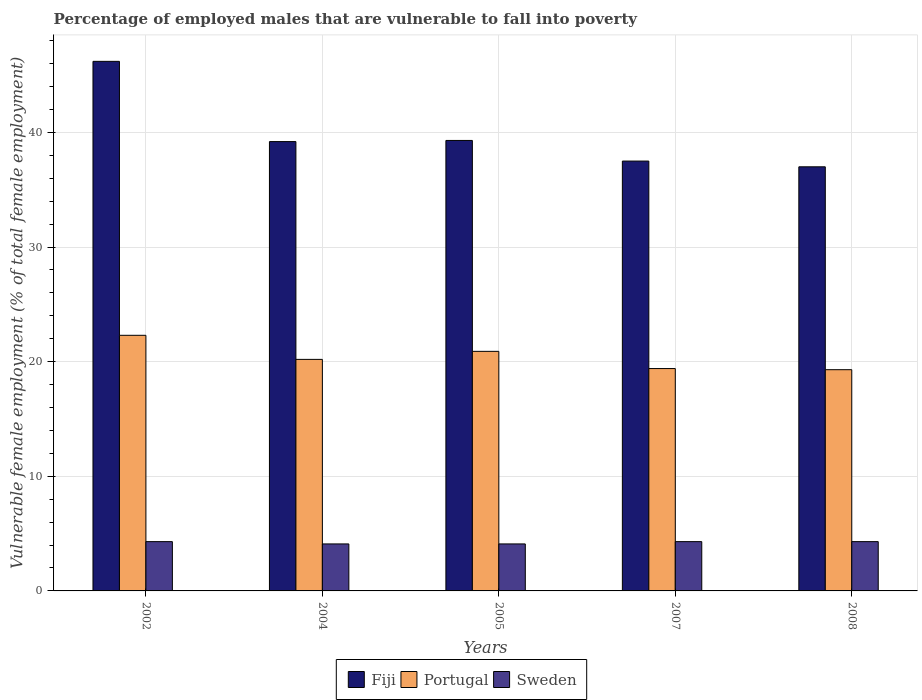How many bars are there on the 5th tick from the left?
Give a very brief answer. 3. How many bars are there on the 5th tick from the right?
Your answer should be compact. 3. What is the percentage of employed males who are vulnerable to fall into poverty in Sweden in 2002?
Keep it short and to the point. 4.3. Across all years, what is the maximum percentage of employed males who are vulnerable to fall into poverty in Sweden?
Ensure brevity in your answer.  4.3. Across all years, what is the minimum percentage of employed males who are vulnerable to fall into poverty in Sweden?
Your answer should be very brief. 4.1. In which year was the percentage of employed males who are vulnerable to fall into poverty in Sweden maximum?
Your response must be concise. 2002. In which year was the percentage of employed males who are vulnerable to fall into poverty in Fiji minimum?
Your answer should be compact. 2008. What is the total percentage of employed males who are vulnerable to fall into poverty in Fiji in the graph?
Offer a very short reply. 199.2. What is the difference between the percentage of employed males who are vulnerable to fall into poverty in Fiji in 2002 and that in 2005?
Your answer should be compact. 6.9. What is the difference between the percentage of employed males who are vulnerable to fall into poverty in Portugal in 2005 and the percentage of employed males who are vulnerable to fall into poverty in Fiji in 2004?
Your response must be concise. -18.3. What is the average percentage of employed males who are vulnerable to fall into poverty in Portugal per year?
Your answer should be compact. 20.42. In the year 2008, what is the difference between the percentage of employed males who are vulnerable to fall into poverty in Fiji and percentage of employed males who are vulnerable to fall into poverty in Sweden?
Ensure brevity in your answer.  32.7. In how many years, is the percentage of employed males who are vulnerable to fall into poverty in Sweden greater than 26 %?
Provide a succinct answer. 0. What is the ratio of the percentage of employed males who are vulnerable to fall into poverty in Fiji in 2004 to that in 2007?
Your answer should be compact. 1.05. Is the difference between the percentage of employed males who are vulnerable to fall into poverty in Fiji in 2004 and 2008 greater than the difference between the percentage of employed males who are vulnerable to fall into poverty in Sweden in 2004 and 2008?
Your answer should be very brief. Yes. What is the difference between the highest and the second highest percentage of employed males who are vulnerable to fall into poverty in Fiji?
Provide a short and direct response. 6.9. What is the difference between the highest and the lowest percentage of employed males who are vulnerable to fall into poverty in Sweden?
Provide a short and direct response. 0.2. What does the 1st bar from the left in 2008 represents?
Give a very brief answer. Fiji. What does the 2nd bar from the right in 2002 represents?
Ensure brevity in your answer.  Portugal. How many bars are there?
Provide a succinct answer. 15. What is the difference between two consecutive major ticks on the Y-axis?
Your answer should be very brief. 10. Are the values on the major ticks of Y-axis written in scientific E-notation?
Give a very brief answer. No. Where does the legend appear in the graph?
Your response must be concise. Bottom center. How many legend labels are there?
Your answer should be very brief. 3. How are the legend labels stacked?
Provide a succinct answer. Horizontal. What is the title of the graph?
Make the answer very short. Percentage of employed males that are vulnerable to fall into poverty. Does "Middle East & North Africa (developing only)" appear as one of the legend labels in the graph?
Offer a terse response. No. What is the label or title of the X-axis?
Give a very brief answer. Years. What is the label or title of the Y-axis?
Offer a terse response. Vulnerable female employment (% of total female employment). What is the Vulnerable female employment (% of total female employment) of Fiji in 2002?
Ensure brevity in your answer.  46.2. What is the Vulnerable female employment (% of total female employment) of Portugal in 2002?
Make the answer very short. 22.3. What is the Vulnerable female employment (% of total female employment) in Sweden in 2002?
Give a very brief answer. 4.3. What is the Vulnerable female employment (% of total female employment) of Fiji in 2004?
Provide a succinct answer. 39.2. What is the Vulnerable female employment (% of total female employment) in Portugal in 2004?
Offer a terse response. 20.2. What is the Vulnerable female employment (% of total female employment) of Sweden in 2004?
Your response must be concise. 4.1. What is the Vulnerable female employment (% of total female employment) of Fiji in 2005?
Offer a terse response. 39.3. What is the Vulnerable female employment (% of total female employment) in Portugal in 2005?
Offer a very short reply. 20.9. What is the Vulnerable female employment (% of total female employment) of Sweden in 2005?
Offer a terse response. 4.1. What is the Vulnerable female employment (% of total female employment) in Fiji in 2007?
Make the answer very short. 37.5. What is the Vulnerable female employment (% of total female employment) in Portugal in 2007?
Offer a very short reply. 19.4. What is the Vulnerable female employment (% of total female employment) of Sweden in 2007?
Keep it short and to the point. 4.3. What is the Vulnerable female employment (% of total female employment) in Fiji in 2008?
Provide a short and direct response. 37. What is the Vulnerable female employment (% of total female employment) of Portugal in 2008?
Keep it short and to the point. 19.3. What is the Vulnerable female employment (% of total female employment) in Sweden in 2008?
Your response must be concise. 4.3. Across all years, what is the maximum Vulnerable female employment (% of total female employment) in Fiji?
Your answer should be compact. 46.2. Across all years, what is the maximum Vulnerable female employment (% of total female employment) of Portugal?
Your response must be concise. 22.3. Across all years, what is the maximum Vulnerable female employment (% of total female employment) in Sweden?
Your answer should be compact. 4.3. Across all years, what is the minimum Vulnerable female employment (% of total female employment) of Portugal?
Provide a succinct answer. 19.3. Across all years, what is the minimum Vulnerable female employment (% of total female employment) in Sweden?
Make the answer very short. 4.1. What is the total Vulnerable female employment (% of total female employment) of Fiji in the graph?
Offer a very short reply. 199.2. What is the total Vulnerable female employment (% of total female employment) of Portugal in the graph?
Provide a succinct answer. 102.1. What is the total Vulnerable female employment (% of total female employment) in Sweden in the graph?
Give a very brief answer. 21.1. What is the difference between the Vulnerable female employment (% of total female employment) in Fiji in 2002 and that in 2004?
Your response must be concise. 7. What is the difference between the Vulnerable female employment (% of total female employment) in Portugal in 2002 and that in 2004?
Keep it short and to the point. 2.1. What is the difference between the Vulnerable female employment (% of total female employment) of Sweden in 2002 and that in 2004?
Provide a succinct answer. 0.2. What is the difference between the Vulnerable female employment (% of total female employment) of Sweden in 2002 and that in 2005?
Offer a very short reply. 0.2. What is the difference between the Vulnerable female employment (% of total female employment) in Sweden in 2002 and that in 2007?
Offer a terse response. 0. What is the difference between the Vulnerable female employment (% of total female employment) of Portugal in 2002 and that in 2008?
Keep it short and to the point. 3. What is the difference between the Vulnerable female employment (% of total female employment) in Sweden in 2002 and that in 2008?
Make the answer very short. 0. What is the difference between the Vulnerable female employment (% of total female employment) of Fiji in 2004 and that in 2005?
Give a very brief answer. -0.1. What is the difference between the Vulnerable female employment (% of total female employment) of Sweden in 2004 and that in 2005?
Your answer should be compact. 0. What is the difference between the Vulnerable female employment (% of total female employment) in Sweden in 2004 and that in 2007?
Make the answer very short. -0.2. What is the difference between the Vulnerable female employment (% of total female employment) in Portugal in 2004 and that in 2008?
Offer a terse response. 0.9. What is the difference between the Vulnerable female employment (% of total female employment) of Sweden in 2005 and that in 2008?
Provide a short and direct response. -0.2. What is the difference between the Vulnerable female employment (% of total female employment) in Fiji in 2007 and that in 2008?
Keep it short and to the point. 0.5. What is the difference between the Vulnerable female employment (% of total female employment) of Fiji in 2002 and the Vulnerable female employment (% of total female employment) of Sweden in 2004?
Make the answer very short. 42.1. What is the difference between the Vulnerable female employment (% of total female employment) of Fiji in 2002 and the Vulnerable female employment (% of total female employment) of Portugal in 2005?
Provide a succinct answer. 25.3. What is the difference between the Vulnerable female employment (% of total female employment) of Fiji in 2002 and the Vulnerable female employment (% of total female employment) of Sweden in 2005?
Your answer should be very brief. 42.1. What is the difference between the Vulnerable female employment (% of total female employment) in Portugal in 2002 and the Vulnerable female employment (% of total female employment) in Sweden in 2005?
Offer a terse response. 18.2. What is the difference between the Vulnerable female employment (% of total female employment) in Fiji in 2002 and the Vulnerable female employment (% of total female employment) in Portugal in 2007?
Make the answer very short. 26.8. What is the difference between the Vulnerable female employment (% of total female employment) of Fiji in 2002 and the Vulnerable female employment (% of total female employment) of Sweden in 2007?
Provide a succinct answer. 41.9. What is the difference between the Vulnerable female employment (% of total female employment) of Fiji in 2002 and the Vulnerable female employment (% of total female employment) of Portugal in 2008?
Your response must be concise. 26.9. What is the difference between the Vulnerable female employment (% of total female employment) of Fiji in 2002 and the Vulnerable female employment (% of total female employment) of Sweden in 2008?
Make the answer very short. 41.9. What is the difference between the Vulnerable female employment (% of total female employment) of Portugal in 2002 and the Vulnerable female employment (% of total female employment) of Sweden in 2008?
Give a very brief answer. 18. What is the difference between the Vulnerable female employment (% of total female employment) in Fiji in 2004 and the Vulnerable female employment (% of total female employment) in Portugal in 2005?
Keep it short and to the point. 18.3. What is the difference between the Vulnerable female employment (% of total female employment) in Fiji in 2004 and the Vulnerable female employment (% of total female employment) in Sweden in 2005?
Keep it short and to the point. 35.1. What is the difference between the Vulnerable female employment (% of total female employment) of Fiji in 2004 and the Vulnerable female employment (% of total female employment) of Portugal in 2007?
Your answer should be very brief. 19.8. What is the difference between the Vulnerable female employment (% of total female employment) in Fiji in 2004 and the Vulnerable female employment (% of total female employment) in Sweden in 2007?
Ensure brevity in your answer.  34.9. What is the difference between the Vulnerable female employment (% of total female employment) in Fiji in 2004 and the Vulnerable female employment (% of total female employment) in Sweden in 2008?
Provide a short and direct response. 34.9. What is the difference between the Vulnerable female employment (% of total female employment) in Portugal in 2004 and the Vulnerable female employment (% of total female employment) in Sweden in 2008?
Provide a succinct answer. 15.9. What is the difference between the Vulnerable female employment (% of total female employment) in Fiji in 2005 and the Vulnerable female employment (% of total female employment) in Sweden in 2007?
Provide a short and direct response. 35. What is the difference between the Vulnerable female employment (% of total female employment) of Portugal in 2005 and the Vulnerable female employment (% of total female employment) of Sweden in 2007?
Provide a short and direct response. 16.6. What is the difference between the Vulnerable female employment (% of total female employment) in Fiji in 2005 and the Vulnerable female employment (% of total female employment) in Sweden in 2008?
Ensure brevity in your answer.  35. What is the difference between the Vulnerable female employment (% of total female employment) of Fiji in 2007 and the Vulnerable female employment (% of total female employment) of Sweden in 2008?
Ensure brevity in your answer.  33.2. What is the average Vulnerable female employment (% of total female employment) in Fiji per year?
Provide a short and direct response. 39.84. What is the average Vulnerable female employment (% of total female employment) of Portugal per year?
Your response must be concise. 20.42. What is the average Vulnerable female employment (% of total female employment) of Sweden per year?
Offer a terse response. 4.22. In the year 2002, what is the difference between the Vulnerable female employment (% of total female employment) in Fiji and Vulnerable female employment (% of total female employment) in Portugal?
Provide a short and direct response. 23.9. In the year 2002, what is the difference between the Vulnerable female employment (% of total female employment) in Fiji and Vulnerable female employment (% of total female employment) in Sweden?
Offer a terse response. 41.9. In the year 2004, what is the difference between the Vulnerable female employment (% of total female employment) in Fiji and Vulnerable female employment (% of total female employment) in Sweden?
Offer a terse response. 35.1. In the year 2005, what is the difference between the Vulnerable female employment (% of total female employment) in Fiji and Vulnerable female employment (% of total female employment) in Sweden?
Your answer should be compact. 35.2. In the year 2007, what is the difference between the Vulnerable female employment (% of total female employment) in Fiji and Vulnerable female employment (% of total female employment) in Portugal?
Offer a very short reply. 18.1. In the year 2007, what is the difference between the Vulnerable female employment (% of total female employment) in Fiji and Vulnerable female employment (% of total female employment) in Sweden?
Your response must be concise. 33.2. In the year 2008, what is the difference between the Vulnerable female employment (% of total female employment) of Fiji and Vulnerable female employment (% of total female employment) of Sweden?
Keep it short and to the point. 32.7. In the year 2008, what is the difference between the Vulnerable female employment (% of total female employment) in Portugal and Vulnerable female employment (% of total female employment) in Sweden?
Offer a very short reply. 15. What is the ratio of the Vulnerable female employment (% of total female employment) in Fiji in 2002 to that in 2004?
Ensure brevity in your answer.  1.18. What is the ratio of the Vulnerable female employment (% of total female employment) of Portugal in 2002 to that in 2004?
Offer a very short reply. 1.1. What is the ratio of the Vulnerable female employment (% of total female employment) of Sweden in 2002 to that in 2004?
Your response must be concise. 1.05. What is the ratio of the Vulnerable female employment (% of total female employment) of Fiji in 2002 to that in 2005?
Keep it short and to the point. 1.18. What is the ratio of the Vulnerable female employment (% of total female employment) in Portugal in 2002 to that in 2005?
Your answer should be very brief. 1.07. What is the ratio of the Vulnerable female employment (% of total female employment) of Sweden in 2002 to that in 2005?
Provide a succinct answer. 1.05. What is the ratio of the Vulnerable female employment (% of total female employment) of Fiji in 2002 to that in 2007?
Offer a terse response. 1.23. What is the ratio of the Vulnerable female employment (% of total female employment) in Portugal in 2002 to that in 2007?
Your answer should be compact. 1.15. What is the ratio of the Vulnerable female employment (% of total female employment) in Sweden in 2002 to that in 2007?
Offer a very short reply. 1. What is the ratio of the Vulnerable female employment (% of total female employment) in Fiji in 2002 to that in 2008?
Your response must be concise. 1.25. What is the ratio of the Vulnerable female employment (% of total female employment) in Portugal in 2002 to that in 2008?
Your response must be concise. 1.16. What is the ratio of the Vulnerable female employment (% of total female employment) in Sweden in 2002 to that in 2008?
Your response must be concise. 1. What is the ratio of the Vulnerable female employment (% of total female employment) in Portugal in 2004 to that in 2005?
Provide a short and direct response. 0.97. What is the ratio of the Vulnerable female employment (% of total female employment) of Sweden in 2004 to that in 2005?
Offer a very short reply. 1. What is the ratio of the Vulnerable female employment (% of total female employment) in Fiji in 2004 to that in 2007?
Your response must be concise. 1.05. What is the ratio of the Vulnerable female employment (% of total female employment) in Portugal in 2004 to that in 2007?
Your answer should be compact. 1.04. What is the ratio of the Vulnerable female employment (% of total female employment) of Sweden in 2004 to that in 2007?
Offer a terse response. 0.95. What is the ratio of the Vulnerable female employment (% of total female employment) of Fiji in 2004 to that in 2008?
Provide a short and direct response. 1.06. What is the ratio of the Vulnerable female employment (% of total female employment) in Portugal in 2004 to that in 2008?
Offer a very short reply. 1.05. What is the ratio of the Vulnerable female employment (% of total female employment) of Sweden in 2004 to that in 2008?
Offer a terse response. 0.95. What is the ratio of the Vulnerable female employment (% of total female employment) in Fiji in 2005 to that in 2007?
Provide a succinct answer. 1.05. What is the ratio of the Vulnerable female employment (% of total female employment) of Portugal in 2005 to that in 2007?
Offer a very short reply. 1.08. What is the ratio of the Vulnerable female employment (% of total female employment) in Sweden in 2005 to that in 2007?
Make the answer very short. 0.95. What is the ratio of the Vulnerable female employment (% of total female employment) in Fiji in 2005 to that in 2008?
Give a very brief answer. 1.06. What is the ratio of the Vulnerable female employment (% of total female employment) of Portugal in 2005 to that in 2008?
Offer a terse response. 1.08. What is the ratio of the Vulnerable female employment (% of total female employment) in Sweden in 2005 to that in 2008?
Your response must be concise. 0.95. What is the ratio of the Vulnerable female employment (% of total female employment) of Fiji in 2007 to that in 2008?
Offer a very short reply. 1.01. What is the ratio of the Vulnerable female employment (% of total female employment) of Sweden in 2007 to that in 2008?
Give a very brief answer. 1. What is the difference between the highest and the second highest Vulnerable female employment (% of total female employment) of Sweden?
Provide a short and direct response. 0. 